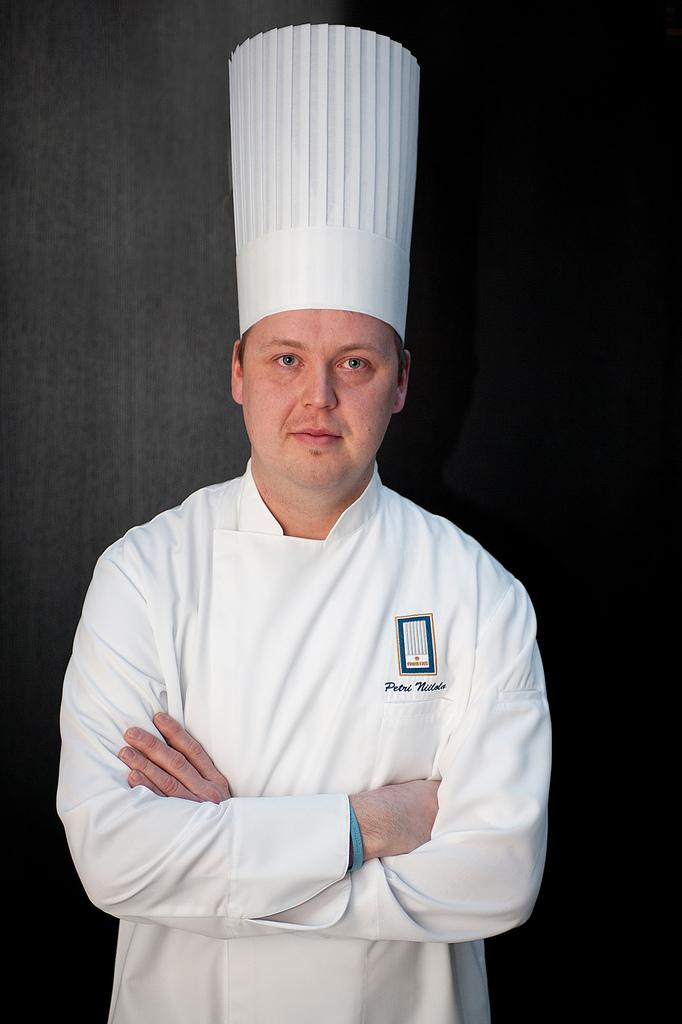What is the main subject of the image? The main subject of the image is a man. What is the man wearing in the image? The man is wearing a cape and a coat in the image. What is the man doing in the image? The man is standing and smiling in the image. What can be observed about the background of the image? The background of the image is dark. What type of test can be seen being conducted in the image? There is no test being conducted in the image; it features a man wearing a cape and a coat while standing and smiling. How many trucks are visible in the image? There are no trucks present in the image. 